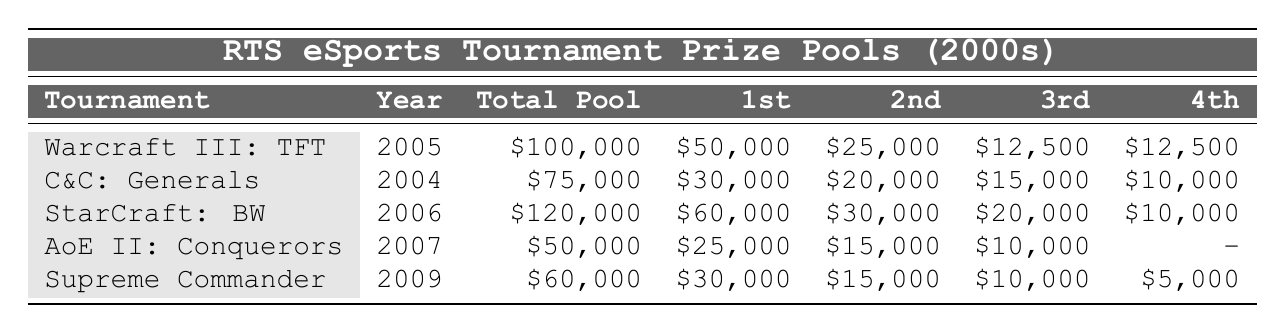What is the total prize pool for the Warcraft III tournament? The table shows the total prize pool for the Warcraft III: The Frozen Throne World Championship as $100,000.
Answer: $100,000 Which tournament had the highest prize for the first place? Examining the table, the StarCraft: Brood War World Championship has the highest first place prize of $60,000.
Answer: $60,000 What was the prize for the fourth place in the Command & Conquer: Generals tournament? The table indicates that the prize for the fourth place in the Command & Conquer: Generals World Series is $10,000.
Answer: $10,000 How much more was the total prize pool for StarCraft: Brood War compared to Age of Empires II? To find the difference, subtract the total prize pool of Age of Empires II ($50,000) from StarCraft: Brood War ($120,000), resulting in $120,000 - $50,000 = $70,000.
Answer: $70,000 What is the average prize for the second place across all tournaments listed? The second place prizes are $25,000, $20,000, $30,000, $15,000, and $15,000. The sum is $25,000 + $20,000 + $30,000 + $15,000 + $15,000 = $105,000. Then, divide by 5 (the number of tournaments), giving an average of $105,000 / 5 = $21,000.
Answer: $21,000 Is there a tournament with no fourth place prize listed? Yes, in the Age of Empires II: The Conquerors Tournament, there is no fourth place prize mentioned in the table.
Answer: Yes Which tournament had a lower total prize pool, Command & Conquer: Generals or Supreme Commander? The total prize pool for Command & Conquer: Generals is $75,000, while for Supreme Commander it is $60,000. Comparing these values, Supreme Commander has the lower total prize pool.
Answer: Supreme Commander What was the total prize amount awarded to the top three places in the Warcraft III tournament? The top three prizes are $50,000 (1st), $25,000 (2nd), and $12,500 (3rd). Adding these amounts gives $50,000 + $25,000 + $12,500 = $87,500.
Answer: $87,500 Which year had the highest total prize pool for an RTS tournament? Looking at the years and their respective prize pools, 2006 with the StarCraft: Brood War World Championship had the highest total prize pool at $120,000.
Answer: 2006 How much did the second place prize decrease from the C&C: Generals tournament to the Supreme Commander tournament? The second place prize for C&C: Generals is $20,000, while for Supreme Commander it is $15,000. The decrease is calculated as $20,000 - $15,000 = $5,000.
Answer: $5,000 